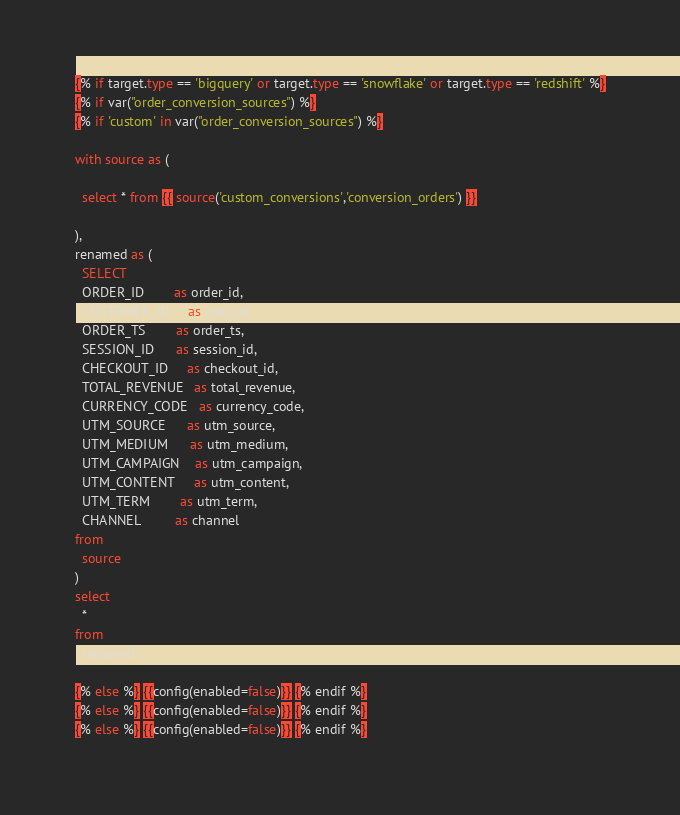Convert code to text. <code><loc_0><loc_0><loc_500><loc_500><_SQL_>{% if target.type == 'bigquery' or target.type == 'snowflake' or target.type == 'redshift' %}
{% if var("order_conversion_sources") %}
{% if 'custom' in var("order_conversion_sources") %}

with source as (

  select * from {{ source('custom_conversions','conversion_orders') }}

),
renamed as (
  SELECT
  ORDER_ID        as order_id,
  CUSTOMER_ID     as user_id,
  ORDER_TS        as order_ts,
  SESSION_ID      as session_id,
  CHECKOUT_ID     as checkout_id,
  TOTAL_REVENUE   as total_revenue,
  CURRENCY_CODE   as currency_code,
  UTM_SOURCE      as utm_source,
  UTM_MEDIUM      as utm_medium,
  UTM_CAMPAIGN    as utm_campaign,
  UTM_CONTENT     as utm_content,
  UTM_TERM        as utm_term,
  CHANNEL         as channel
from
  source
)
select
  *
from
  renamed

{% else %} {{config(enabled=false)}} {% endif %}
{% else %} {{config(enabled=false)}} {% endif %}
{% else %} {{config(enabled=false)}} {% endif %}
</code> 